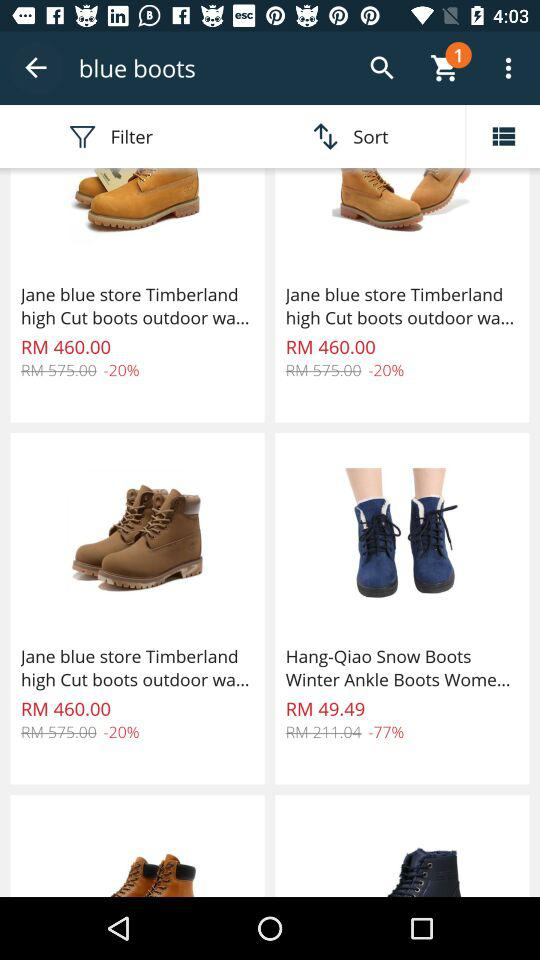How many items are in the cart?
Answer the question using a single word or phrase. 1 